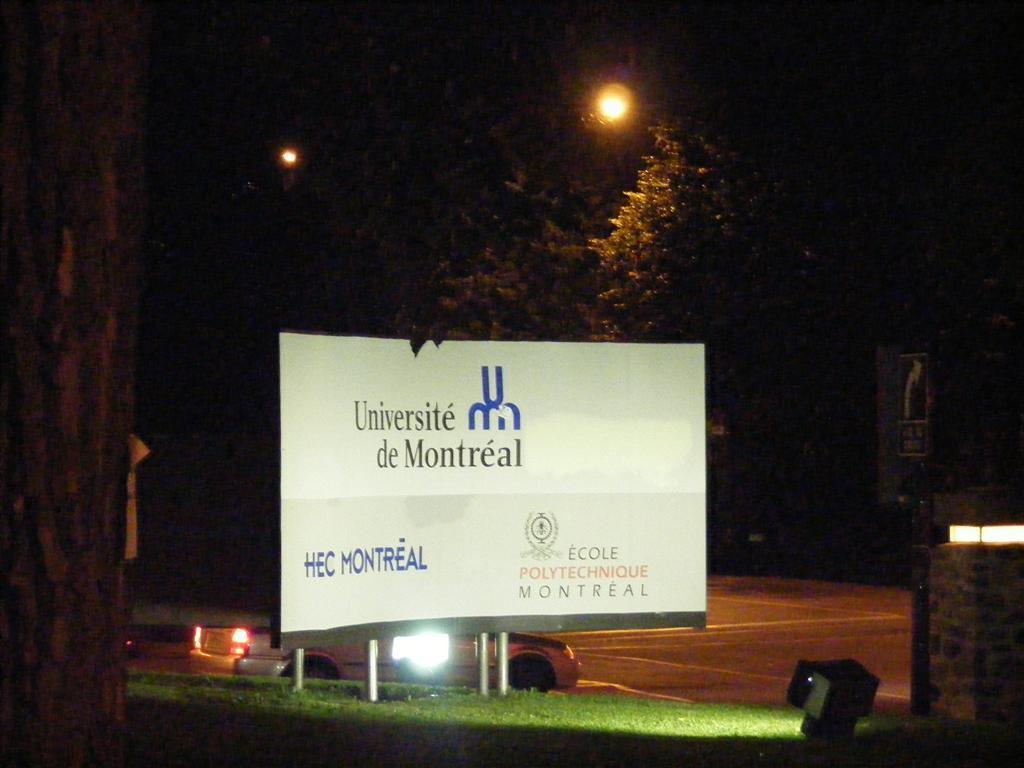Please provide a concise description of this image. In the foreground of the picture we can see focus light, board, grass, trunk of a tree, wall and other objects. In the middle of the picture there are trees, street lights, car and road. On the right we can see a sign board. 